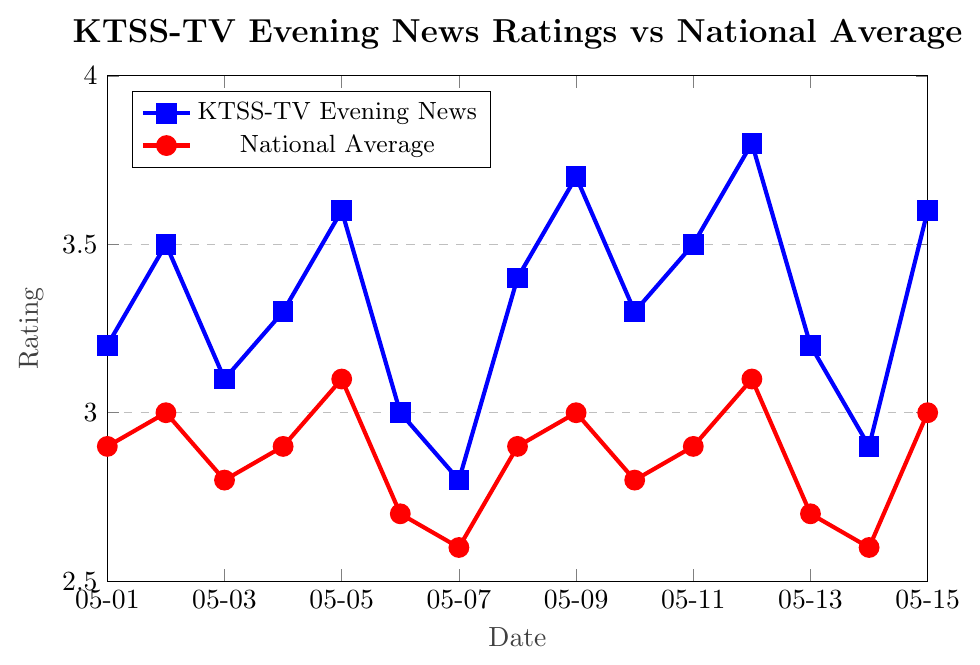What is the rating of KTSS-TV Evening News on May 5th? The specific date is May 5th, and we look for the corresponding value on the blue line. The rating for KTSS-TV on this date is 3.6.
Answer: 3.6 On which date does the KTSS-TV Evening News rating first fall below 3.0? We need to find the first occurrence where the blue line is below the 3.0 mark. This happens on May 7th.
Answer: May 7th What is the difference between the highest rating of KTSS-TV Evening News and the lowest rating of the National Average? The highest KTSS-TV rating (blue) is 3.8 on May 12th, and the lowest National Average rating (red) is 2.6 on May 7th and May 14th, so the difference is 3.8 - 2.6 = 1.2.
Answer: 1.2 Which dates have KTSS-TV Evening News ratings greater than the National Average? For each date, check if the blue line value is higher than the red line value. The dates are May 1st, May 2nd, May 3rd, May 4th, May 5th, May 8th, May 9th, May 10th, May 11th, May 12th, May 13th, and May 15th.
Answer: May 1st, May 2nd, May 3rd, May 4th, May 5th, May 8th, May 9th, May 10th, May 11th, May 12th, May 13th, May 15th Calculate the average rating for the KTSS-TV Evening News from May 1st to May 7th? Add the ratings of KTSS-TV from May 1st to May 7th (3.2 + 3.5 + 3.1 + 3.3 + 3.6 + 3.0 + 2.8) and divide by the number of days (7). The sum is 22.5, so the average is 22.5 / 7 ≈ 3.21.
Answer: 3.21 On which date do both KTSS-TV Evening News and National Average ratings show the same value? Check where the blue and red lines intersect. This happens on no date; the lines do not intersect during the specified range.
Answer: None What is the overall trend observed for KTSS-TV Evening News ratings from May 1st to May 15th? The trend shows some fluctuations but generally remains above the 3.0 mark, with an increasing trend towards the end, peaking at 3.8 on May 12th and ending at 3.6 on May 15th.
Answer: Increasing trend Compare the rating changes from May 1st to May 2nd for both KTSS-TV Evening News and the National Average. Calculate the difference in ratings between May 1st and May 2nd for KTSS-TV (3.5 - 3.2 = 0.3) and the National Average (3.0 - 2.9 = 0.1). KTSS-TV increased by 0.3, whereas the National Average increased by 0.1.
Answer: KTSS-TV increased more What is the median rating for the National Average from May 1st to May 15th? List the National Average ratings in ascending order: 2.6, 2.6, 2.7, 2.7, 2.8, 2.8, 2.9, 2.9, 2.9, 2.9, 3.0, 3.0, 3.0, 3.1, 3.1. The median is the middle value, which is the 8th value in this ordered list, i.e., 2.9.
Answer: 2.9 